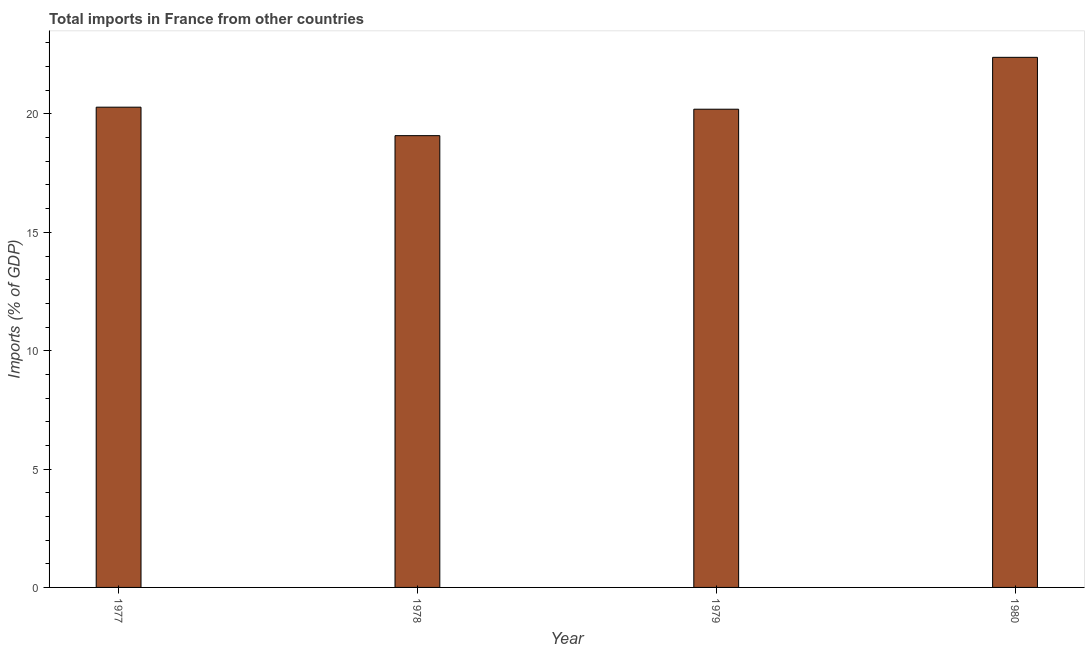What is the title of the graph?
Your response must be concise. Total imports in France from other countries. What is the label or title of the Y-axis?
Your answer should be very brief. Imports (% of GDP). What is the total imports in 1980?
Offer a terse response. 22.39. Across all years, what is the maximum total imports?
Your answer should be very brief. 22.39. Across all years, what is the minimum total imports?
Make the answer very short. 19.08. In which year was the total imports minimum?
Ensure brevity in your answer.  1978. What is the sum of the total imports?
Offer a terse response. 81.97. What is the difference between the total imports in 1977 and 1979?
Give a very brief answer. 0.09. What is the average total imports per year?
Keep it short and to the point. 20.49. What is the median total imports?
Offer a terse response. 20.24. What is the ratio of the total imports in 1977 to that in 1978?
Keep it short and to the point. 1.06. What is the difference between the highest and the second highest total imports?
Provide a succinct answer. 2.11. What is the difference between the highest and the lowest total imports?
Provide a short and direct response. 3.31. In how many years, is the total imports greater than the average total imports taken over all years?
Provide a short and direct response. 1. What is the difference between two consecutive major ticks on the Y-axis?
Ensure brevity in your answer.  5. What is the Imports (% of GDP) in 1977?
Offer a terse response. 20.29. What is the Imports (% of GDP) in 1978?
Your response must be concise. 19.08. What is the Imports (% of GDP) of 1979?
Provide a short and direct response. 20.2. What is the Imports (% of GDP) of 1980?
Ensure brevity in your answer.  22.39. What is the difference between the Imports (% of GDP) in 1977 and 1978?
Your response must be concise. 1.2. What is the difference between the Imports (% of GDP) in 1977 and 1979?
Make the answer very short. 0.09. What is the difference between the Imports (% of GDP) in 1977 and 1980?
Provide a short and direct response. -2.11. What is the difference between the Imports (% of GDP) in 1978 and 1979?
Give a very brief answer. -1.12. What is the difference between the Imports (% of GDP) in 1978 and 1980?
Offer a terse response. -3.31. What is the difference between the Imports (% of GDP) in 1979 and 1980?
Give a very brief answer. -2.19. What is the ratio of the Imports (% of GDP) in 1977 to that in 1978?
Ensure brevity in your answer.  1.06. What is the ratio of the Imports (% of GDP) in 1977 to that in 1979?
Your answer should be very brief. 1. What is the ratio of the Imports (% of GDP) in 1977 to that in 1980?
Give a very brief answer. 0.91. What is the ratio of the Imports (% of GDP) in 1978 to that in 1979?
Keep it short and to the point. 0.94. What is the ratio of the Imports (% of GDP) in 1978 to that in 1980?
Offer a terse response. 0.85. What is the ratio of the Imports (% of GDP) in 1979 to that in 1980?
Provide a succinct answer. 0.9. 